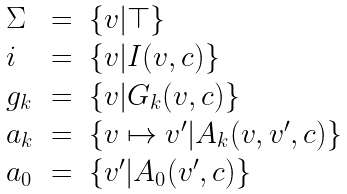Convert formula to latex. <formula><loc_0><loc_0><loc_500><loc_500>\begin{array} { l c l } \Sigma & = & \{ v | \top \} \\ i & = & \{ v | I ( v , c ) \} \\ g _ { k } & = & \{ v | G _ { k } ( v , c ) \} \\ a _ { k } & = & \{ v \mapsto v ^ { \prime } | A _ { k } ( v , v ^ { \prime } , c ) \} \\ a _ { 0 } & = & \{ v ^ { \prime } | A _ { 0 } ( v ^ { \prime } , c ) \} \end{array}</formula> 